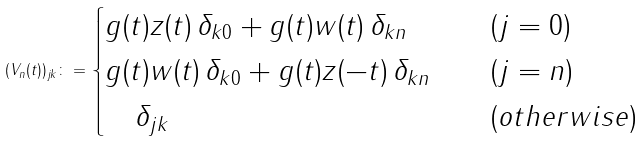Convert formula to latex. <formula><loc_0><loc_0><loc_500><loc_500>( V _ { n } ( t ) ) _ { j k } \colon = { \begin{cases} g ( t ) z ( t ) \, \delta _ { k 0 } + g ( t ) w ( t ) \, \delta _ { k n } & \quad ( j = 0 ) \\ g ( t ) { w ( t ) } \, \delta _ { k 0 } + g ( t ) { z ( - t ) } \, \delta _ { k n } & \quad ( j = n ) \\ \quad \delta _ { j k } & \quad ( o t h e r w i s e ) \end{cases} }</formula> 